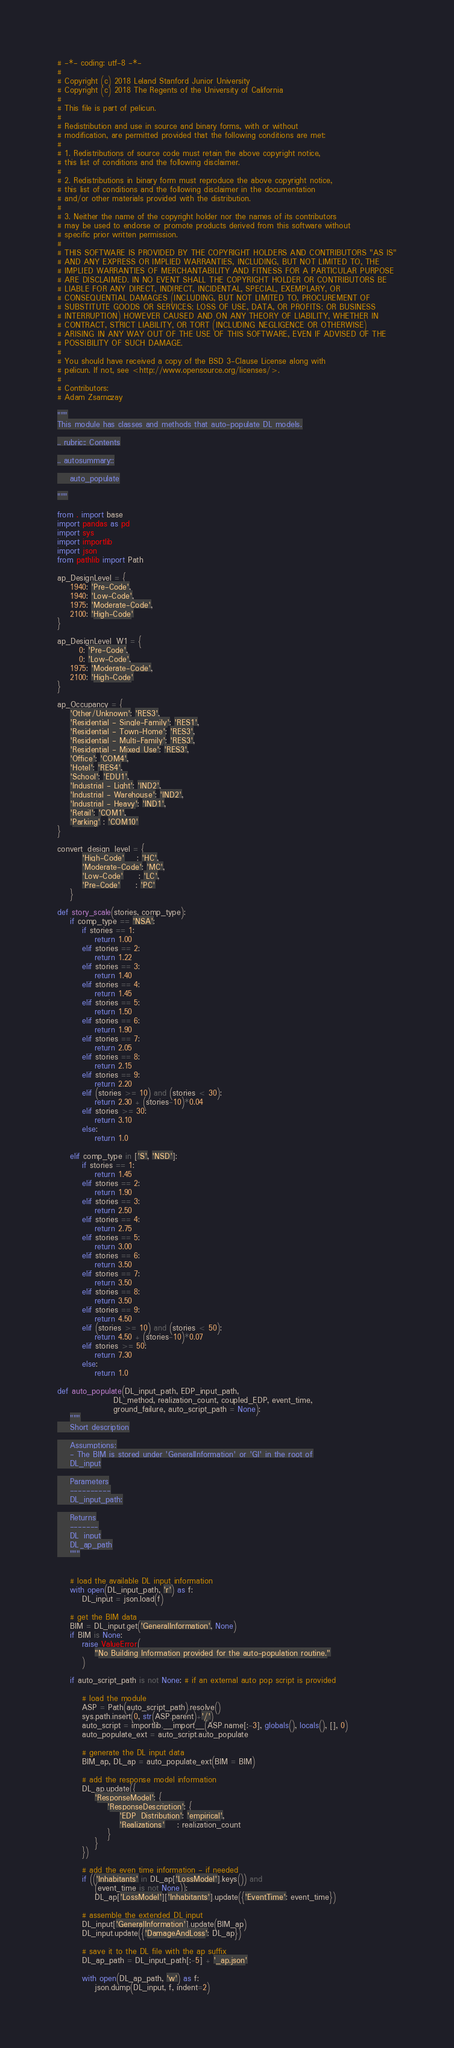<code> <loc_0><loc_0><loc_500><loc_500><_Python_># -*- coding: utf-8 -*-
#
# Copyright (c) 2018 Leland Stanford Junior University
# Copyright (c) 2018 The Regents of the University of California
#
# This file is part of pelicun.
#
# Redistribution and use in source and binary forms, with or without
# modification, are permitted provided that the following conditions are met:
#
# 1. Redistributions of source code must retain the above copyright notice,
# this list of conditions and the following disclaimer.
#
# 2. Redistributions in binary form must reproduce the above copyright notice,
# this list of conditions and the following disclaimer in the documentation
# and/or other materials provided with the distribution.
#
# 3. Neither the name of the copyright holder nor the names of its contributors
# may be used to endorse or promote products derived from this software without
# specific prior written permission.
#
# THIS SOFTWARE IS PROVIDED BY THE COPYRIGHT HOLDERS AND CONTRIBUTORS "AS IS"
# AND ANY EXPRESS OR IMPLIED WARRANTIES, INCLUDING, BUT NOT LIMITED TO, THE
# IMPLIED WARRANTIES OF MERCHANTABILITY AND FITNESS FOR A PARTICULAR PURPOSE
# ARE DISCLAIMED. IN NO EVENT SHALL THE COPYRIGHT HOLDER OR CONTRIBUTORS BE
# LIABLE FOR ANY DIRECT, INDIRECT, INCIDENTAL, SPECIAL, EXEMPLARY, OR
# CONSEQUENTIAL DAMAGES (INCLUDING, BUT NOT LIMITED TO, PROCUREMENT OF
# SUBSTITUTE GOODS OR SERVICES; LOSS OF USE, DATA, OR PROFITS; OR BUSINESS
# INTERRUPTION) HOWEVER CAUSED AND ON ANY THEORY OF LIABILITY, WHETHER IN
# CONTRACT, STRICT LIABILITY, OR TORT (INCLUDING NEGLIGENCE OR OTHERWISE)
# ARISING IN ANY WAY OUT OF THE USE OF THIS SOFTWARE, EVEN IF ADVISED OF THE
# POSSIBILITY OF SUCH DAMAGE.
#
# You should have received a copy of the BSD 3-Clause License along with
# pelicun. If not, see <http://www.opensource.org/licenses/>.
#
# Contributors:
# Adam Zsarnóczay

"""
This module has classes and methods that auto-populate DL models.

.. rubric:: Contents

.. autosummary::

    auto_populate

"""

from . import base
import pandas as pd
import sys
import importlib
import json
from pathlib import Path

ap_DesignLevel = {
    1940: 'Pre-Code',
    1940: 'Low-Code',
    1975: 'Moderate-Code',
    2100: 'High-Code'
}

ap_DesignLevel_W1 = {
       0: 'Pre-Code',
       0: 'Low-Code',
    1975: 'Moderate-Code',
    2100: 'High-Code'
}

ap_Occupancy = {
    'Other/Unknown': 'RES3',
    'Residential - Single-Family': 'RES1',
    'Residential - Town-Home': 'RES3',
    'Residential - Multi-Family': 'RES3',
    'Residential - Mixed Use': 'RES3',
    'Office': 'COM4',
    'Hotel': 'RES4',
    'School': 'EDU1',
    'Industrial - Light': 'IND2',
    'Industrial - Warehouse': 'IND2',
    'Industrial - Heavy': 'IND1',
    'Retail': 'COM1',
    'Parking' : 'COM10'
}

convert_design_level = {
        'High-Code'    : 'HC',
        'Moderate-Code': 'MC',
        'Low-Code'     : 'LC',
        'Pre-Code'     : 'PC'
    }

def story_scale(stories, comp_type):
    if comp_type == 'NSA':
        if stories == 1:
            return 1.00
        elif stories == 2:
            return 1.22
        elif stories == 3:
            return 1.40
        elif stories == 4:
            return 1.45
        elif stories == 5:
            return 1.50
        elif stories == 6:
            return 1.90
        elif stories == 7:
            return 2.05
        elif stories == 8:
            return 2.15
        elif stories == 9:
            return 2.20
        elif (stories >= 10) and (stories < 30):
            return 2.30 + (stories-10)*0.04
        elif stories >= 30:
            return 3.10
        else:
            return 1.0

    elif comp_type in ['S', 'NSD']:
        if stories == 1:
            return 1.45
        elif stories == 2:
            return 1.90
        elif stories == 3:
            return 2.50
        elif stories == 4:
            return 2.75
        elif stories == 5:
            return 3.00
        elif stories == 6:
            return 3.50
        elif stories == 7:
            return 3.50
        elif stories == 8:
            return 3.50
        elif stories == 9:
            return 4.50
        elif (stories >= 10) and (stories < 50):
            return 4.50 + (stories-10)*0.07
        elif stories >= 50:
            return 7.30
        else:
            return 1.0

def auto_populate(DL_input_path, EDP_input_path,
                  DL_method, realization_count, coupled_EDP, event_time,
                  ground_failure, auto_script_path = None):
    """
    Short description

    Assumptions:
    - The BIM is stored under 'GeneralInformation' or 'GI' in the root of
    DL_input

    Parameters
    ----------
    DL_input_path:

    Returns
    -------
    DL_input
    DL_ap_path
    """


    # load the available DL input information
    with open(DL_input_path, 'r') as f:
        DL_input = json.load(f)

    # get the BIM data
    BIM = DL_input.get('GeneralInformation', None)
    if BIM is None:
        raise ValueError(
            "No Building Information provided for the auto-population routine."
        )

    if auto_script_path is not None: # if an external auto pop script is provided

        # load the module
        ASP = Path(auto_script_path).resolve()
        sys.path.insert(0, str(ASP.parent)+'/')
        auto_script = importlib.__import__(ASP.name[:-3], globals(), locals(), [], 0)
        auto_populate_ext = auto_script.auto_populate

        # generate the DL input data
        BIM_ap, DL_ap = auto_populate_ext(BIM = BIM)

        # add the response model information
        DL_ap.update({
            'ResponseModel': {
                'ResponseDescription': {
                    'EDP_Distribution': 'empirical',
                    'Realizations'    : realization_count
                }
            }
        })

        # add the even time information - if needed
        if (('Inhabitants' in DL_ap['LossModel'].keys()) and
            (event_time is not None)):
            DL_ap['LossModel']['Inhabitants'].update({'EventTime': event_time})

        # assemble the extended DL input
        DL_input['GeneralInformation'].update(BIM_ap)
        DL_input.update({'DamageAndLoss': DL_ap})

        # save it to the DL file with the ap suffix
        DL_ap_path = DL_input_path[:-5] + '_ap.json'

        with open(DL_ap_path, 'w') as f:
            json.dump(DL_input, f, indent=2)
</code> 